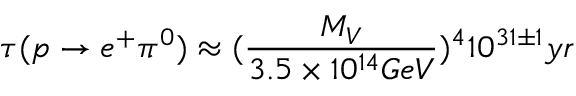Convert formula to latex. <formula><loc_0><loc_0><loc_500><loc_500>\tau ( p \rightarrow e ^ { + } \pi ^ { 0 } ) \approx ( \frac { M _ { V } } { 3 . 5 \times 1 0 ^ { 1 4 } G e V } ) ^ { 4 } 1 0 ^ { 3 1 \pm 1 } y r</formula> 